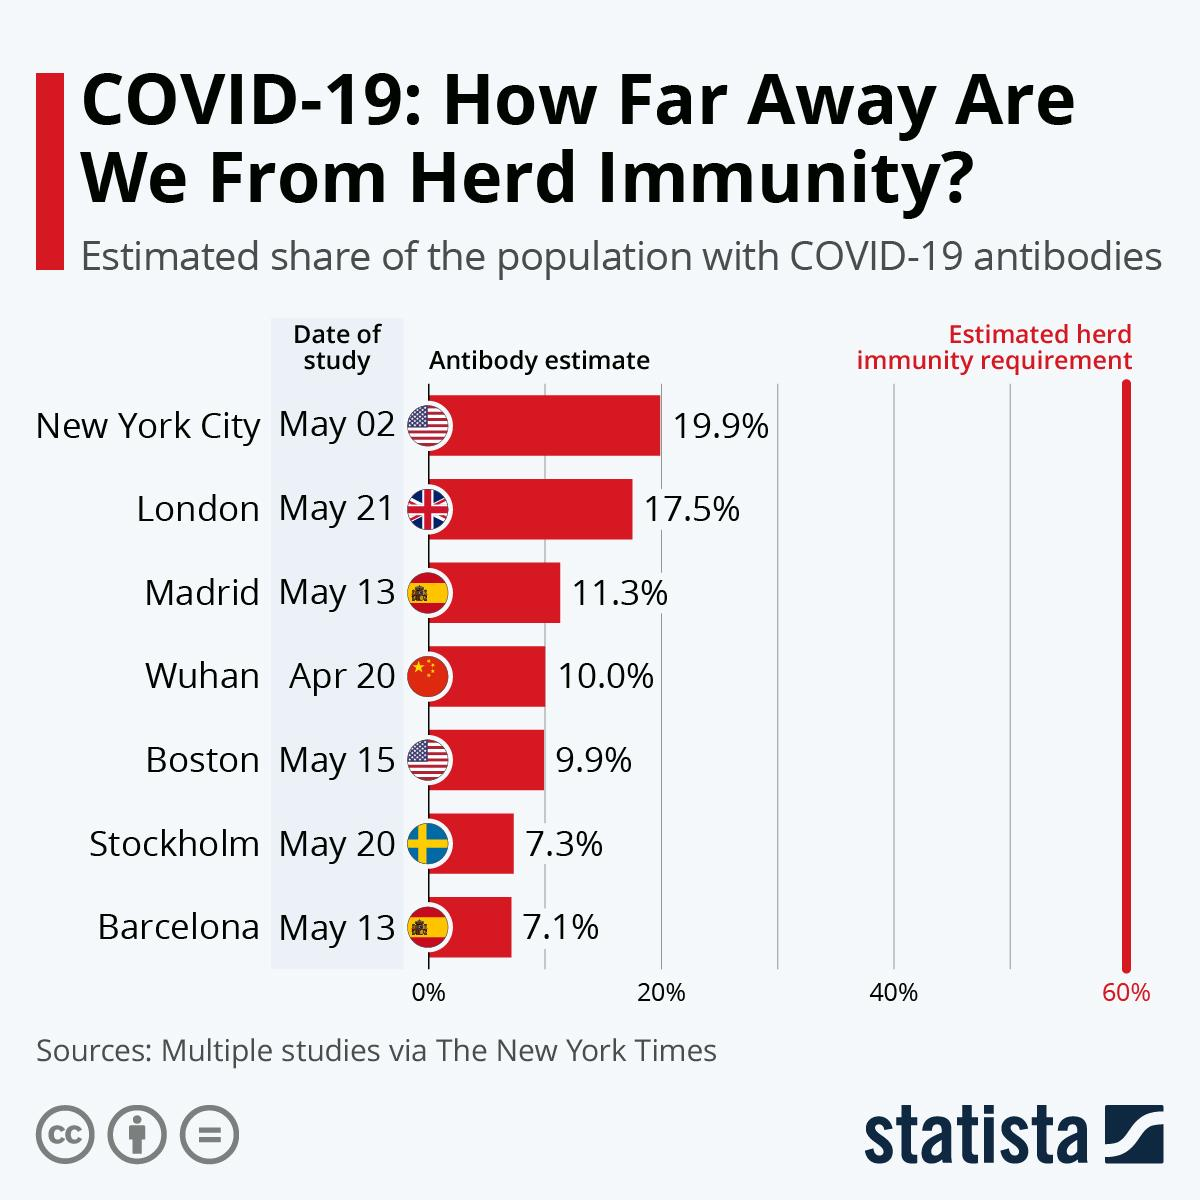Specify some key components in this picture. New York City has the highest estimated percentage of antibodies. The estimated herd immunity requirement is 60%. The cities of Boston, Stockholm, and Barcelona have antibody estimates below 10%. London has the second highest antibody estimate among all cities. To achieve herd immunity, Wuhan needs to increase its antibody estimate by 50%. 